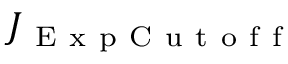Convert formula to latex. <formula><loc_0><loc_0><loc_500><loc_500>J _ { E x p C u t o f f }</formula> 